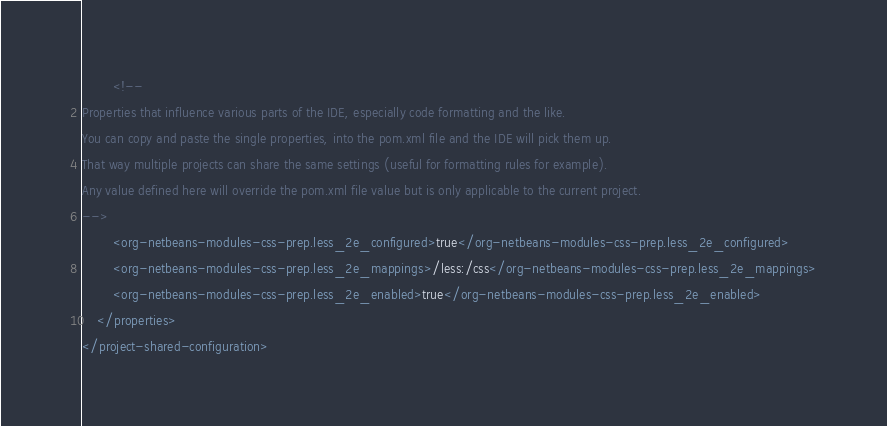Convert code to text. <code><loc_0><loc_0><loc_500><loc_500><_XML_>        <!--
Properties that influence various parts of the IDE, especially code formatting and the like. 
You can copy and paste the single properties, into the pom.xml file and the IDE will pick them up.
That way multiple projects can share the same settings (useful for formatting rules for example).
Any value defined here will override the pom.xml file value but is only applicable to the current project.
-->
        <org-netbeans-modules-css-prep.less_2e_configured>true</org-netbeans-modules-css-prep.less_2e_configured>
        <org-netbeans-modules-css-prep.less_2e_mappings>/less:/css</org-netbeans-modules-css-prep.less_2e_mappings>
        <org-netbeans-modules-css-prep.less_2e_enabled>true</org-netbeans-modules-css-prep.less_2e_enabled>
    </properties>
</project-shared-configuration>
</code> 